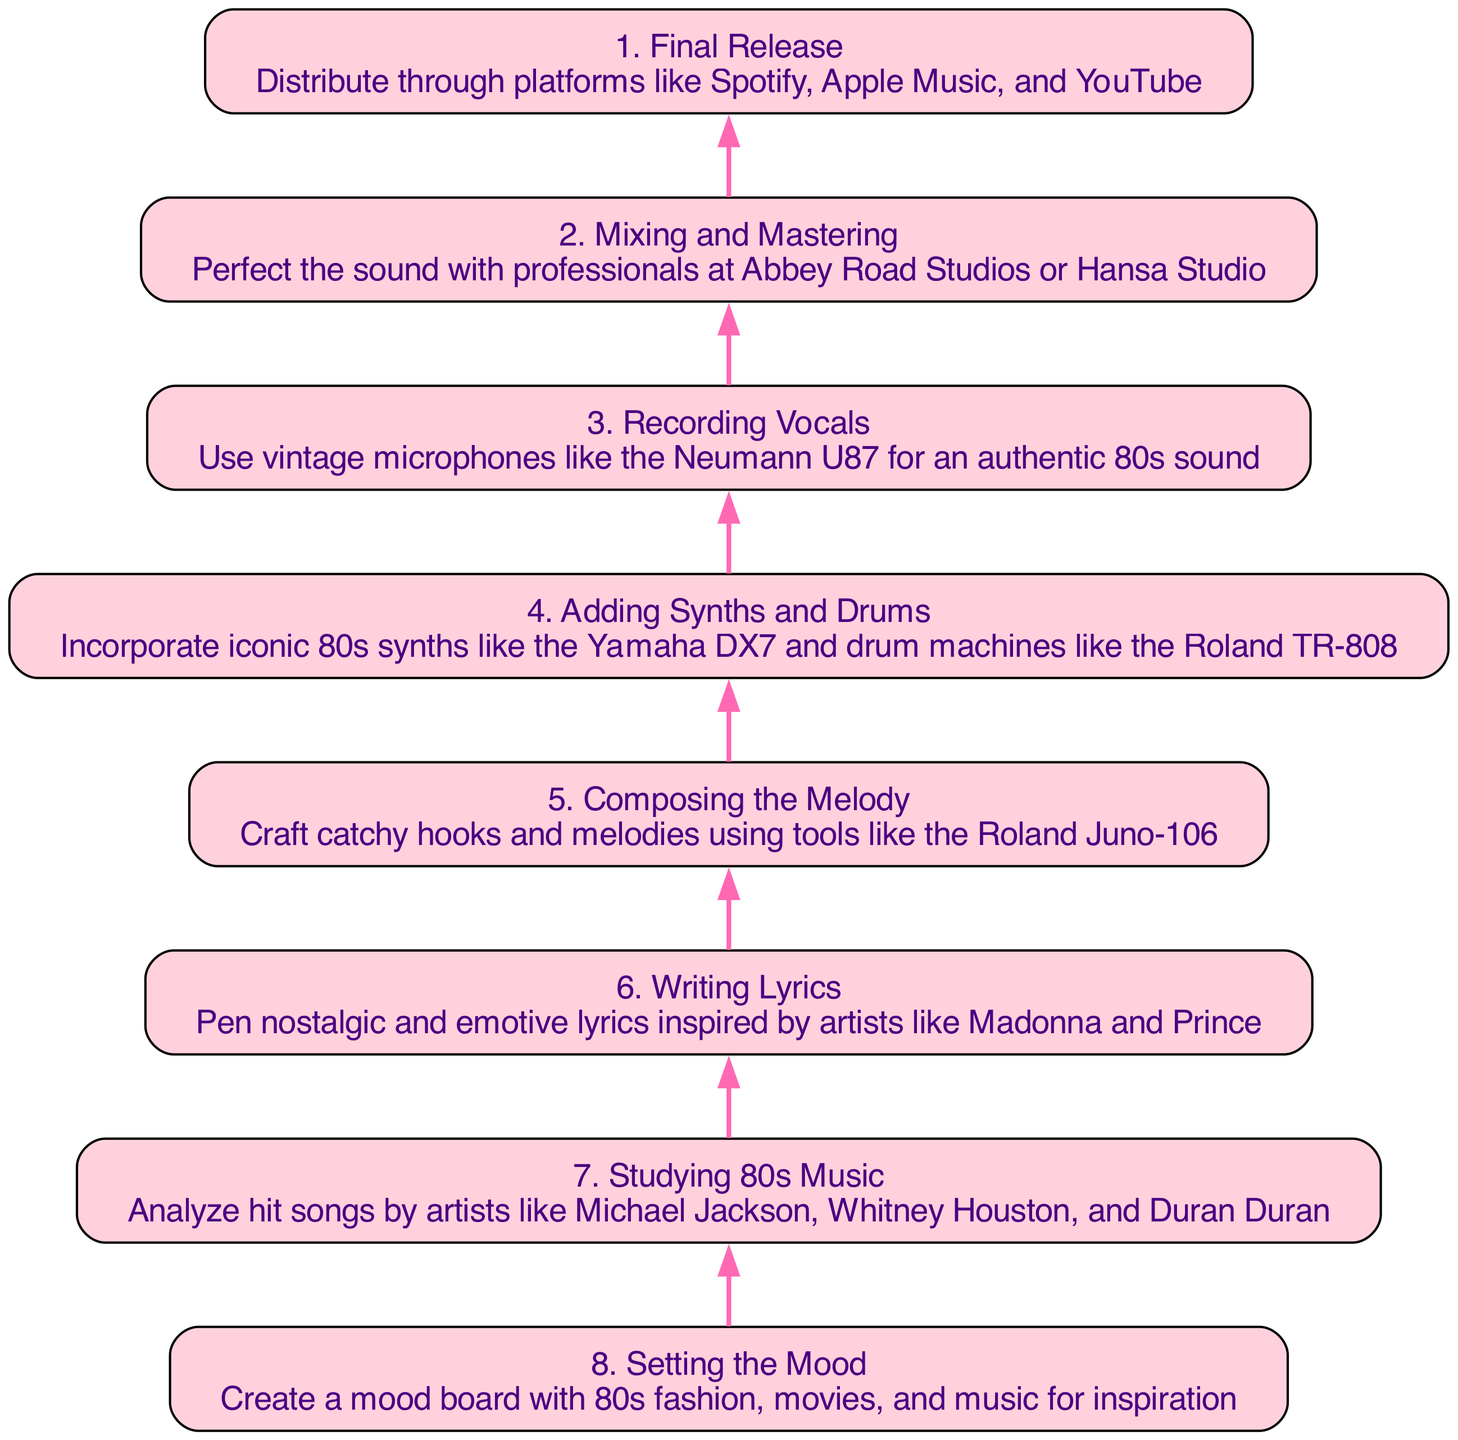What is the final step in the flow chart? The last step in the flow chart is "Final Release," which indicates that the distribution of the song occurs through various platforms. Since the flow is from bottom to up, this is the topmost node and represents the outcome of the entire process.
Answer: Final Release How many steps are there in total? By counting each node in the diagram from the bottom to the top, we can see there are eight specific steps laid out in the flow. Therefore, the total number of steps in the flow chart is eight.
Answer: 8 What node comes before "Mixing and Mastering"? The node "Recording Vocals" is directly connected to "Mixing and Mastering" below it, as indicated by the flow direction from bottom to up. This means that "Recording Vocals" is the step immediately prior in the process.
Answer: Recording Vocals What song elements should be added before mixing and mastering? The step before mixing and mastering is "Adding Synths and Drums," which means that both synths and drum elements should be incorporated into the track before reaching the mixing and mastering stage.
Answer: Adding Synths and Drums Which step involves exploring 80s music for inspiration? The step "Studying 80s Music" focuses on analyzing hit songs from that era, which is crucial for gaining inspiration and understanding the foundational elements in crafting an 80s-inspired track. This step is positioned towards the starting point, indicating its importance early in the creative process.
Answer: Studying 80s Music Which step is directly related to writing the song lyrics? The node "Writing Lyrics" corresponds directly to lyrics creation, suggesting that this is a tailored element designed for crafting the words that accompany the melody. It appears just before the recording and mixing processes, indicating its sequential importance.
Answer: Writing Lyrics What should be created to set the mood for the song? To set the mood for the song, the flow chart indicates creating a mood board that includes elements of 80s fashion, movies, and music, which serves as inspiration throughout the songwriting process. This is the first step explored in the flow, implying its foundational role.
Answer: Create a mood board What vintage microphone is recommended for recording? The chart specifies the Neumann U87 as the vintage microphone recommended for recording vocals, emphasizing its use for achieving an authentic 80s sound. This detail is found in the "Recording Vocals" step which comes after arranging elements.
Answer: Neumann U87 